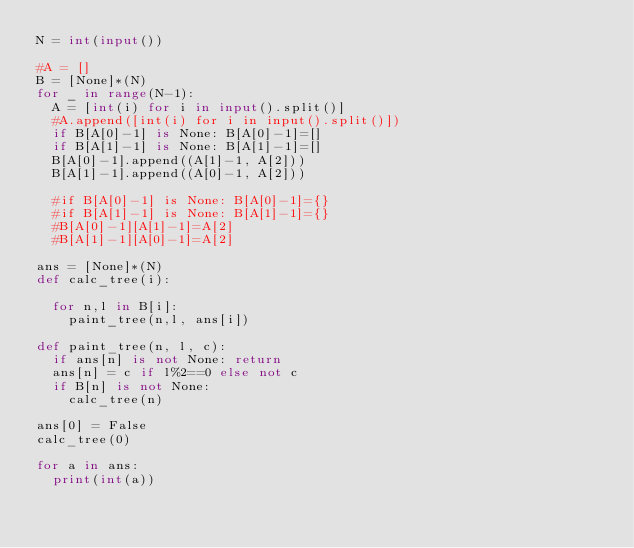<code> <loc_0><loc_0><loc_500><loc_500><_Python_>N = int(input())

#A = []
B = [None]*(N)
for _ in range(N-1):
  A = [int(i) for i in input().split()]
  #A.append([int(i) for i in input().split()])
  if B[A[0]-1] is None: B[A[0]-1]=[]
  if B[A[1]-1] is None: B[A[1]-1]=[]
  B[A[0]-1].append((A[1]-1, A[2]))
  B[A[1]-1].append((A[0]-1, A[2]))
  
  #if B[A[0]-1] is None: B[A[0]-1]={}
  #if B[A[1]-1] is None: B[A[1]-1]={}
  #B[A[0]-1][A[1]-1]=A[2]
  #B[A[1]-1][A[0]-1]=A[2]

ans = [None]*(N)
def calc_tree(i):

  for n,l in B[i]:
    paint_tree(n,l, ans[i])
  
def paint_tree(n, l, c):
  if ans[n] is not None: return
  ans[n] = c if l%2==0 else not c
  if B[n] is not None:
    calc_tree(n)

ans[0] = False
calc_tree(0)

for a in ans:
  print(int(a))</code> 